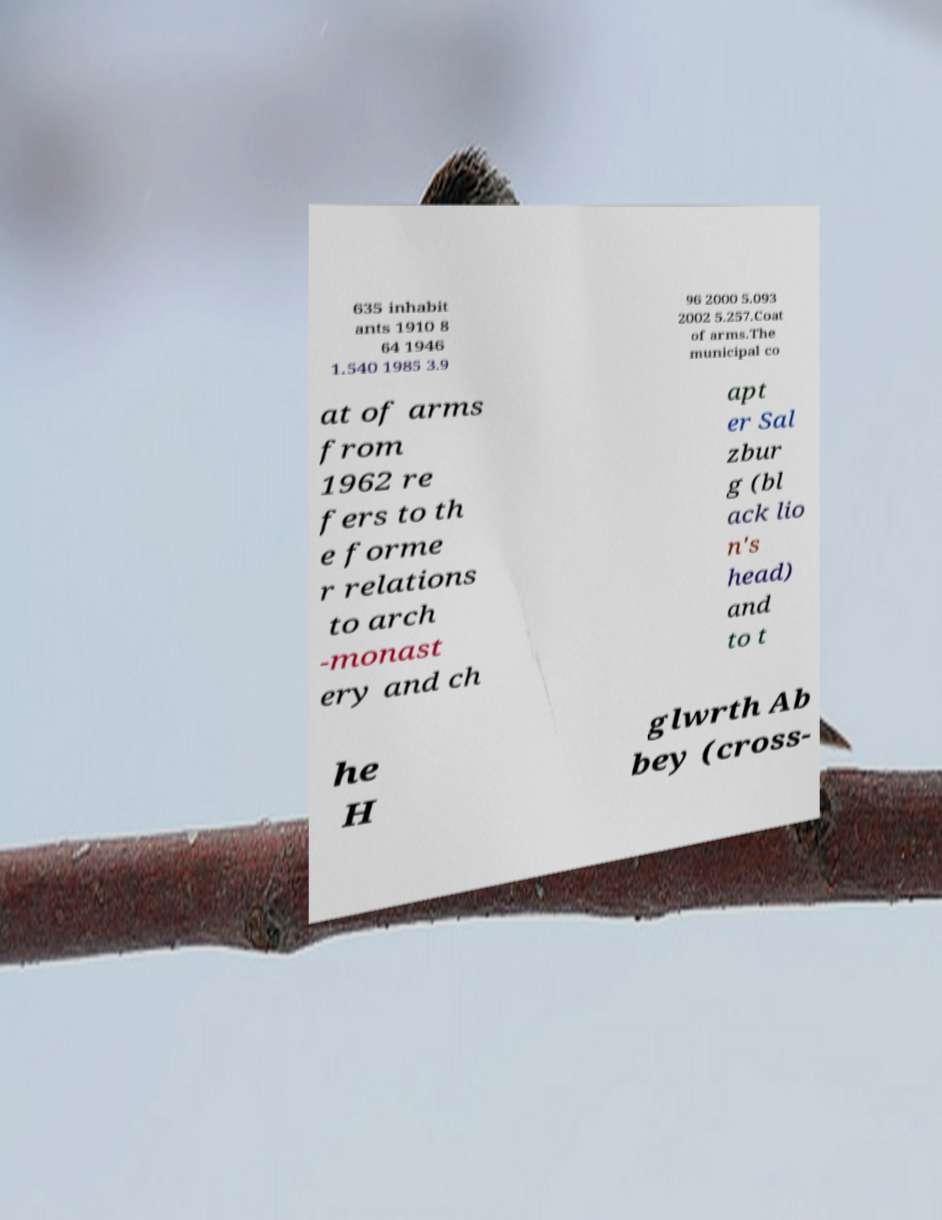I need the written content from this picture converted into text. Can you do that? 635 inhabit ants 1910 8 64 1946 1.540 1985 3.9 96 2000 5.093 2002 5.257.Coat of arms.The municipal co at of arms from 1962 re fers to th e forme r relations to arch -monast ery and ch apt er Sal zbur g (bl ack lio n's head) and to t he H glwrth Ab bey (cross- 